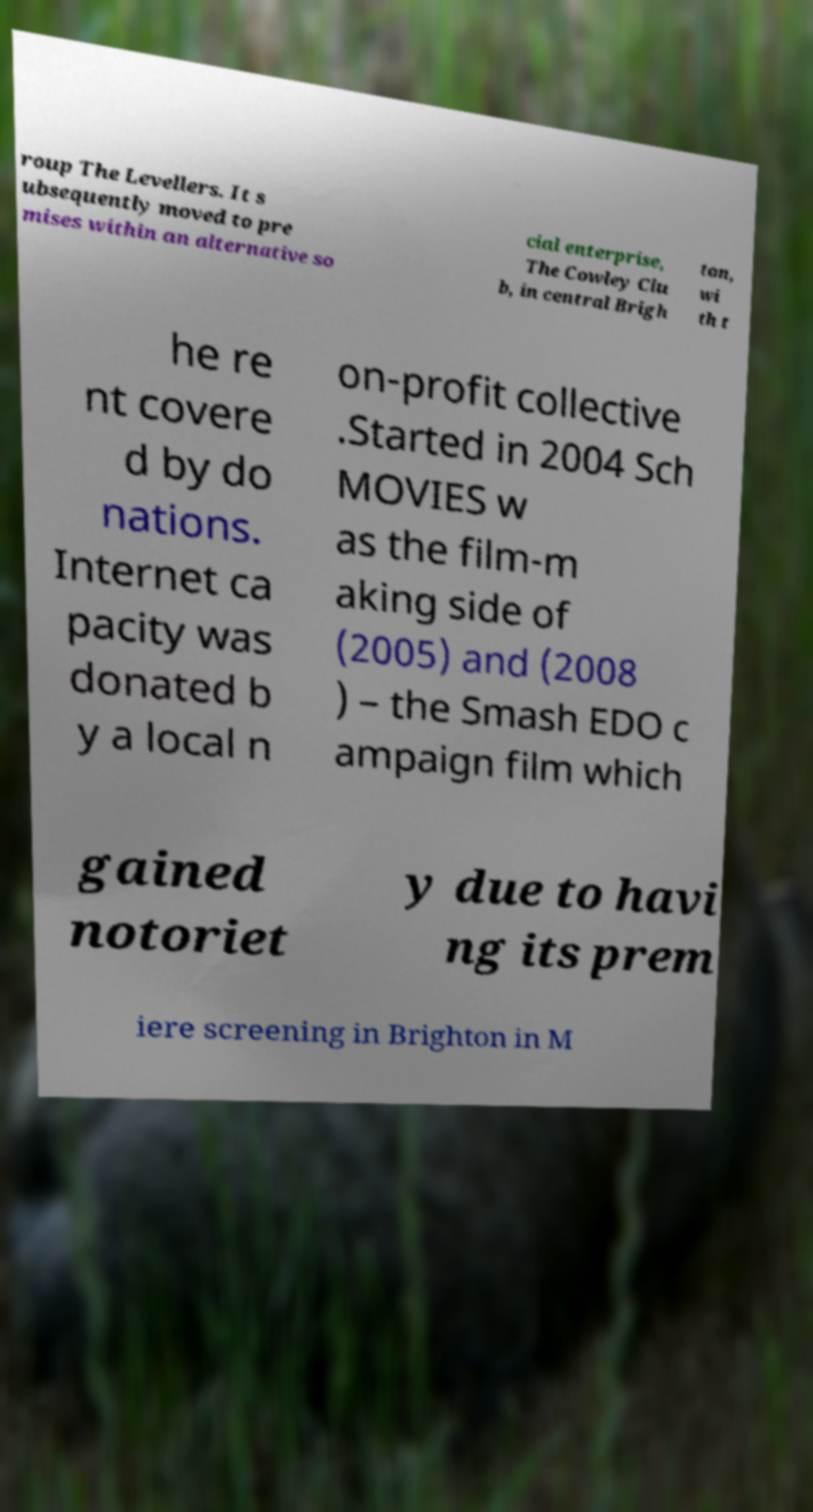What messages or text are displayed in this image? I need them in a readable, typed format. roup The Levellers. It s ubsequently moved to pre mises within an alternative so cial enterprise, The Cowley Clu b, in central Brigh ton, wi th t he re nt covere d by do nations. Internet ca pacity was donated b y a local n on-profit collective .Started in 2004 Sch MOVIES w as the film-m aking side of (2005) and (2008 ) – the Smash EDO c ampaign film which gained notoriet y due to havi ng its prem iere screening in Brighton in M 